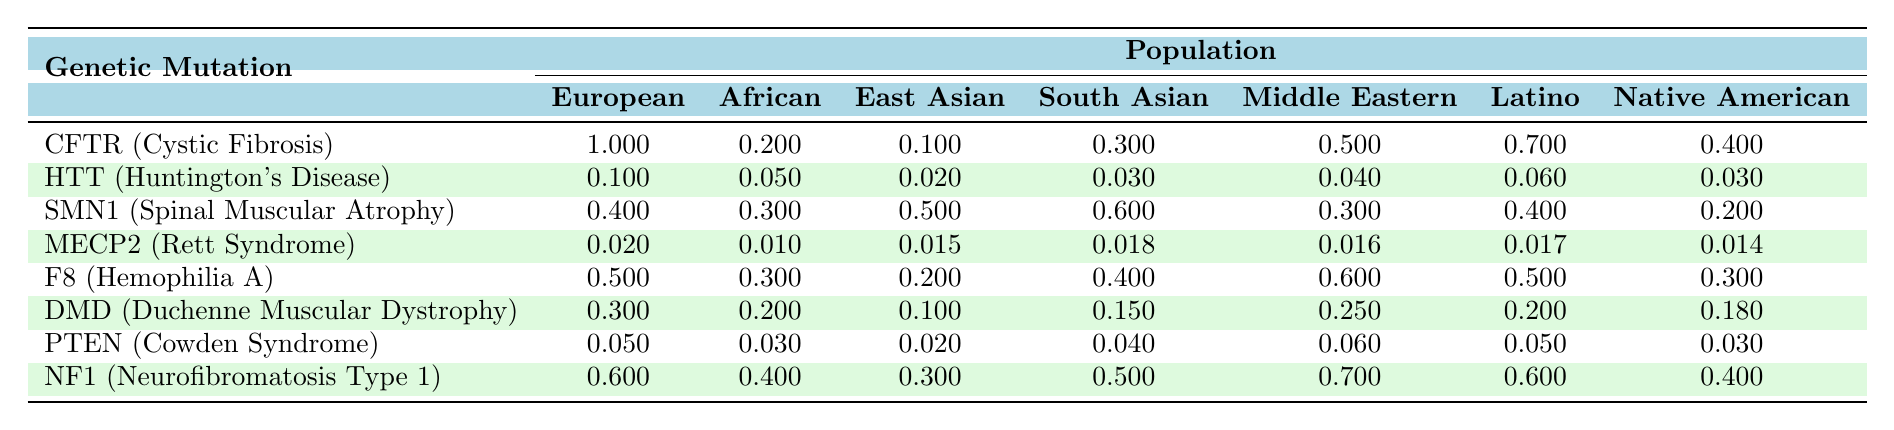What is the frequency of CFTR mutations in the European population? The table shows that the frequency of CFTR mutations in the European population is 1.000.
Answer: 1.000 Which population has the highest frequency of mutations for F8? Looking at the data for F8, the frequency in the Middle Eastern population is 0.600, which is the highest among all populations listed.
Answer: Middle Eastern has the highest frequency What is the frequency of HTT mutations in the African population? The table indicates that the frequency of HTT mutations in the African population is 0.050.
Answer: 0.050 Which mutation has the lowest frequency in the South Asian population? By examining the South Asian row, MECP2 (0.018) has the lowest frequency compared to the other mutations listed for that population.
Answer: MECP2 What is the average frequency of DMD mutations across all populations? To find the average frequency for DMD, sum the values: (0.300 + 0.200 + 0.100 + 0.150 + 0.250 + 0.200 + 0.180) = 1.460 and then divide by 7 (the number of populations), resulting in an average of approximately 0.208.
Answer: 0.208 Is there a mutation with a frequency higher than 0.500 in the Latino population? According to the table, F8 (0.500) and CFTR (0.700) are both examined, but CFTR is the only one above 0.500 in the Latino population.
Answer: Yes Which mutation shows a frequency of greater than 0.500 in the East Asian population? In examining the East Asian column, the mutations SMN1 (0.500), F8 (0.200), and CFTR (0.100) do not exceed 0.500, but SMN1 equals 0.500. However, none exceed that value.
Answer: No What is the relationship in mutation frequency between European and Native American populations for the DMD mutation? For DMD, the frequency in the European population is 0.300 and in the Native American population, it is 0.180. Therefore, the European frequency is higher than that of the Native American population.
Answer: European frequency is higher What is the total frequency of mutations for SMN1 across all populations? Adding the frequencies of SMN1 across all populations gives: 0.400 + 0.300 + 0.500 + 0.600 + 0.300 + 0.400 + 0.200 = 2.700.
Answer: 2.700 Which population experiences the lowest frequency of MECP2 mutations? The data shows that the African population has the lowest frequency for MECP2 at 0.010.
Answer: African population 